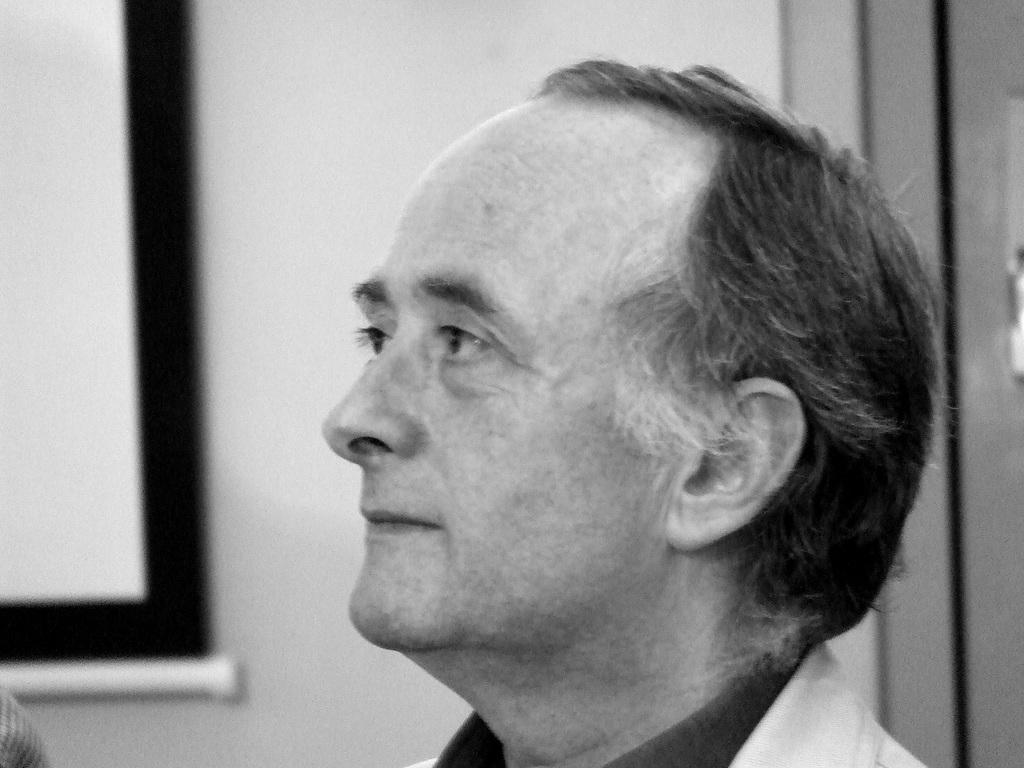What is present in the image? There is a person in the image. What can be seen in the background of the image? There is a wall and objects in the background of the image. How many cherries are on the person's head in the image? There are no cherries present on the person's head in the image. What type of oil can be seen dripping from the objects in the background? There is no oil present in the image, and the objects in the background do not appear to be dripping anything. 